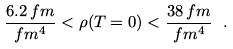<formula> <loc_0><loc_0><loc_500><loc_500>\frac { 6 . 2 \, f m } { f m ^ { 4 } } < \rho ( T = 0 ) < \frac { 3 8 \, f m } { f m ^ { 4 } } \ .</formula> 